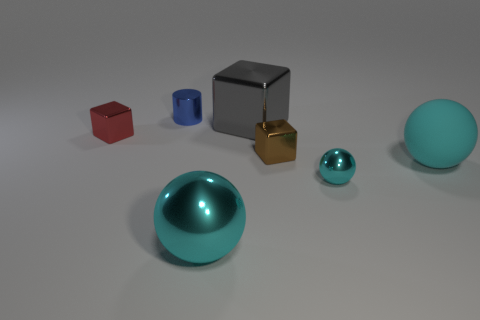How many cyan balls must be subtracted to get 1 cyan balls? 2 Subtract all brown blocks. How many blocks are left? 2 Subtract 1 spheres. How many spheres are left? 2 Subtract all red blocks. How many blocks are left? 2 Subtract 0 green spheres. How many objects are left? 7 Subtract all balls. How many objects are left? 4 Subtract all green balls. Subtract all brown cylinders. How many balls are left? 3 Subtract all yellow cylinders. How many brown blocks are left? 1 Subtract all tiny metal spheres. Subtract all gray metal things. How many objects are left? 5 Add 4 shiny blocks. How many shiny blocks are left? 7 